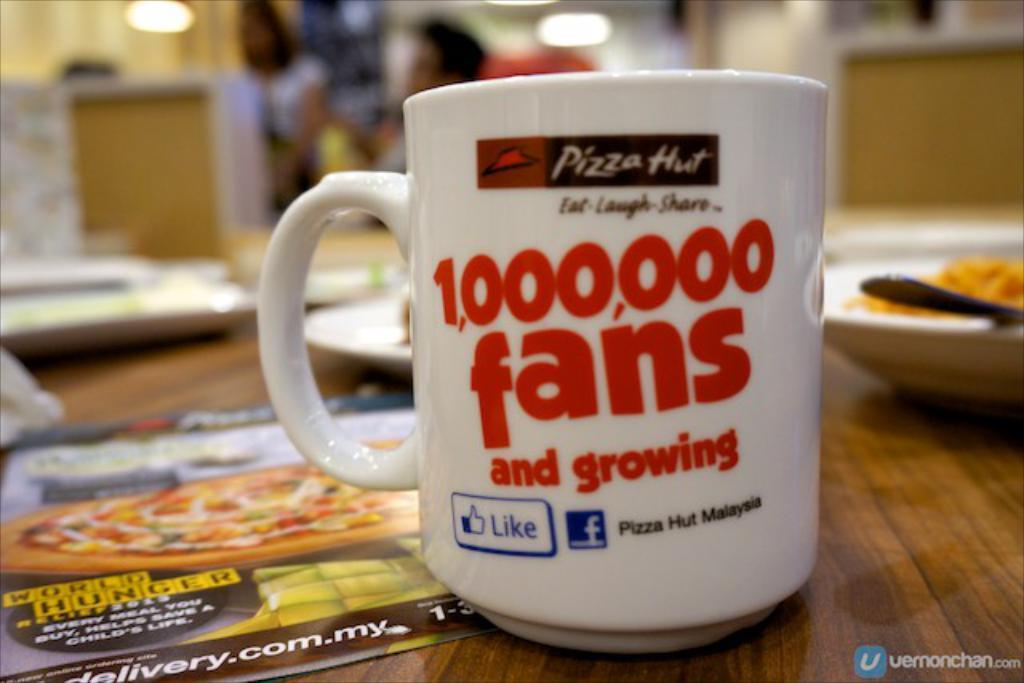Provide a one-sentence caption for the provided image. A mug on a Pizza Hut table that says 1,000,000 fans and growing. 